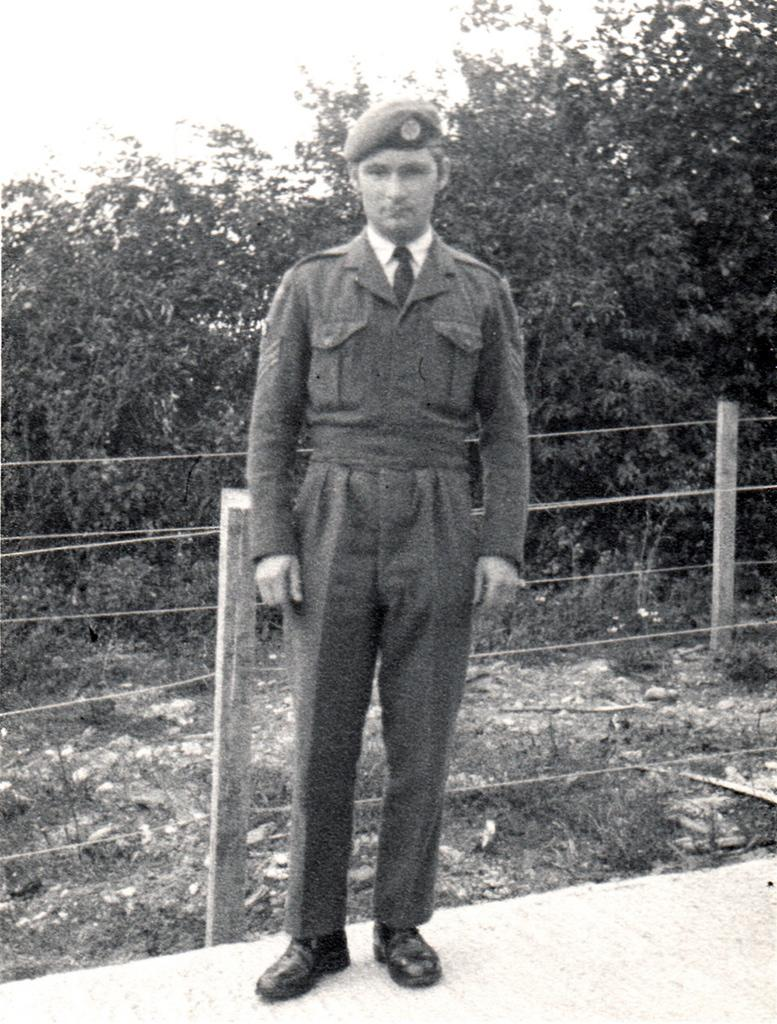What is the main subject of the image? There is a man standing in the image. Where is the man standing? The man is standing on the ground. What can be seen in the image besides the man? There is a fence in the image. What is visible in the background of the image? There are trees in the background of the image. Can you hear the bell ringing in the image? There is no bell present in the image, so it cannot be heard. Is there a fight happening between the man and the trees in the image? There is no fight depicted in the image; the man is simply standing and the trees are in the background. 